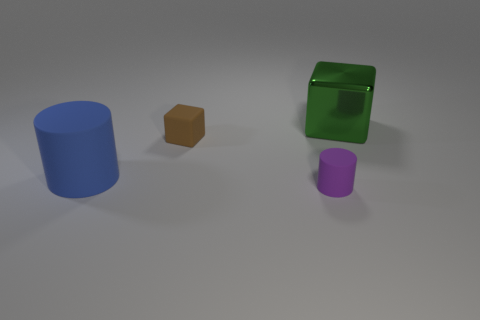Add 4 tiny cylinders. How many objects exist? 8 Subtract 0 purple cubes. How many objects are left? 4 Subtract all large blue things. Subtract all purple rubber cylinders. How many objects are left? 2 Add 4 small cylinders. How many small cylinders are left? 5 Add 4 red metal spheres. How many red metal spheres exist? 4 